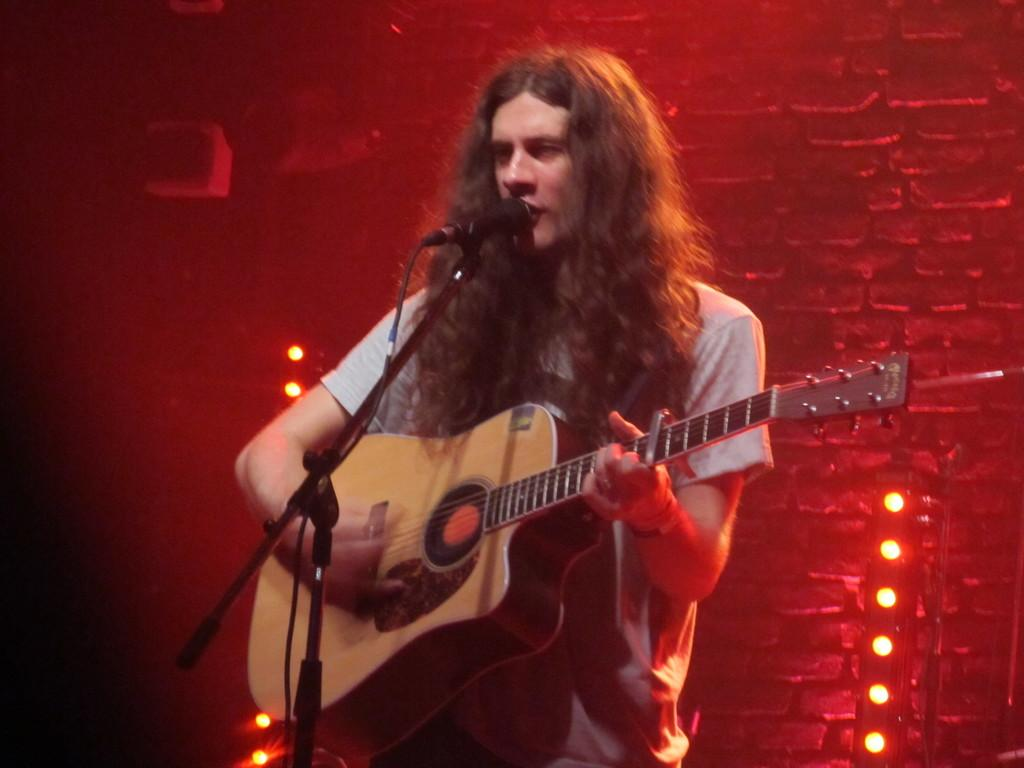What is the person in the image doing? The person is playing the guitar and singing a song. What object is the person using to amplify their voice? There is a microphone behind the person. What can be seen in the background of the image? Red color lights are present in the image. Can you see a man jumping over a wooden fence in the image? No, there is no man jumping over a wooden fence in the image. The image features a person playing the guitar and singing, with a microphone and red color lights in the background. 